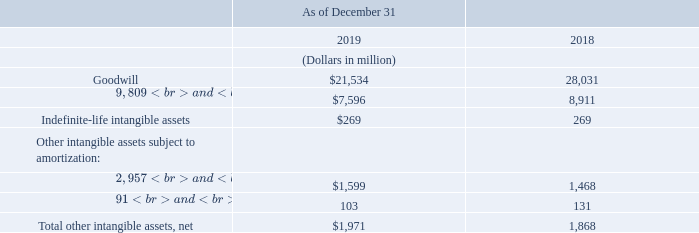(4) Goodwill, Customer Relationships and Other Intangible Assets
Goodwill, customer relationships and other intangible assets consisted of the following:
Our goodwill was derived from numerous acquisitions where the purchase price exceeded the fair value of the net assets acquired (including the acquisition described in Note 2—Acquisition of Level 3). As of December 31, 2019, the weighted average remaining useful lives of the intangible assets were approximately 8 years in total, approximately 9 years for customer relationships, 4 years for capitalized software and 3 years for trade names.
Total amortization expense for intangible assets for the years ended December 31, 2019, 2018 and 2017 was $1.7 billion, $1.8 billion and $1.2 billion, respectively. As of December 31, 2019, the gross carrying amount of goodwill, customer relationships, indefinite-life and other intangible assets was $44.0 billion.
How was goodwill derived? From numerous acquisitions where the purchase price exceeded the fair value of the net assets acquired (including the acquisition described in note 2—acquisition of level 3). What was the gross carrying amount of goodwill, customer relationships, indefinite-life and other intangible assets as of December 31, 2019? $44.0 billion. The weighted average remaining useful lives of which items were provided? Intangible assets, customer relationships, capitalized software, trade names. Which item has the longest weighted average remaining useful life? 9>8>4>3
Answer: customer relationships. What is the total amortization expense for intangible assets for 2017, 2018 and 2019?
Answer scale should be: billion. $1.7+$1.8+$1.2
Answer: 4.7. What is the percentage change in total other intangible assets, net from 2018 to 2019?
Answer scale should be: percent. (1,971-1,868)/1,868
Answer: 5.51. 